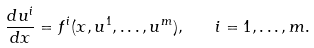Convert formula to latex. <formula><loc_0><loc_0><loc_500><loc_500>\frac { d u ^ { i } } { d x } = f ^ { i } ( x , u ^ { 1 } , \dots , u ^ { m } ) , \quad i = 1 , \dots , m .</formula> 